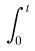Convert formula to latex. <formula><loc_0><loc_0><loc_500><loc_500>\int _ { 0 } ^ { t }</formula> 